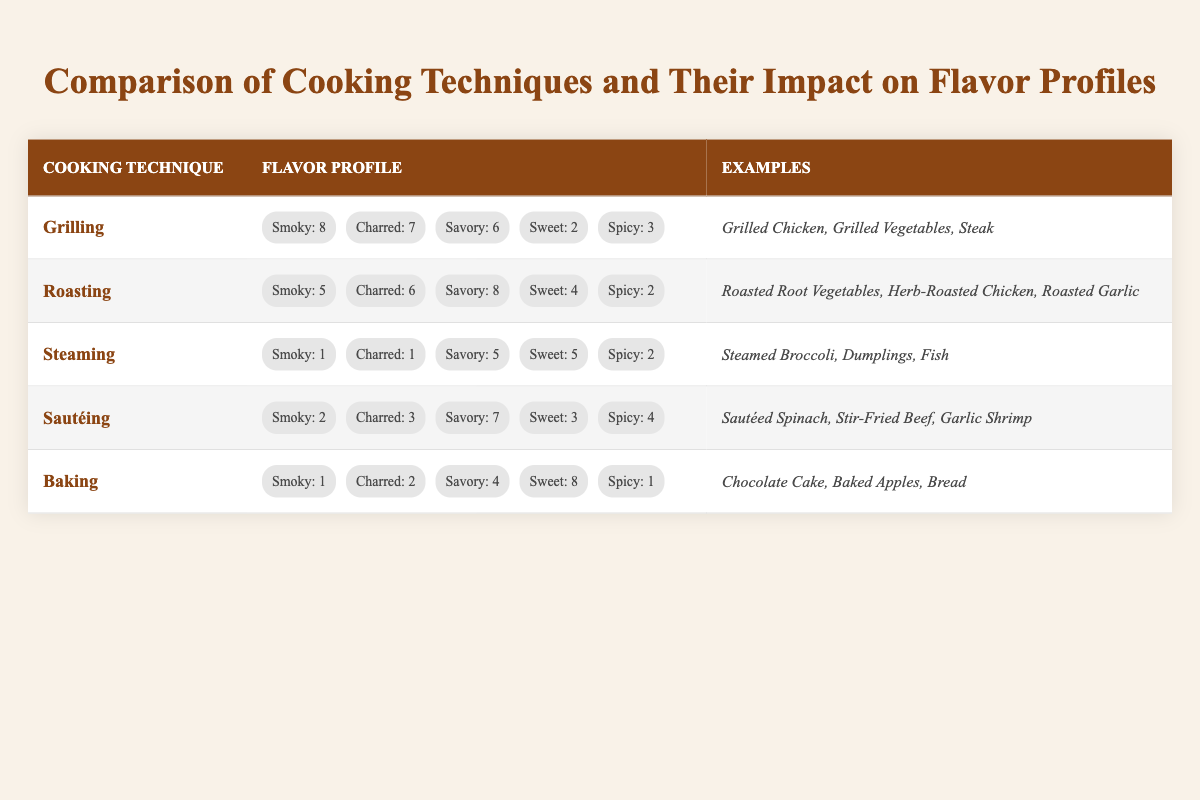What is the flavor profile score for grilling? The flavor profile scores for grilling are as follows: Smoky: 8, Charred: 7, Savory: 6, Sweet: 2, Spicy: 3. These values can be found directly in the table under the grilling technique row.
Answer: Smoky: 8, Charred: 7, Savory: 6, Sweet: 2, Spicy: 3 Which cooking technique has the highest score for sweetness? The scores for sweetness in each cooking technique are: Grilling: 2, Roasting: 4, Steaming: 5, Sautéing: 3, and Baking: 8. Therefore, Baking has the highest score with a value of 8.
Answer: Baking: 8 Are there any cooking techniques that do not have a charred flavor profile? By examining the table, Steaming and Baking have charred flavor profile scores of 1 and 2 respectively. Therefore, while none of the techniques completely lack charred flavor, Steaming has the lowest charred score.
Answer: No What is the difference in savory flavor profile scores between roasting and sautéing? Roasting has a savory score of 8, while sautéing has a savory score of 7. The difference is calculated as 8 - 7 = 1.
Answer: 1 Which cooking technique has the most balanced flavor profile overall? To determine the balance, we can consider the range from the lowest to the highest scores across each technique. The scores are as follows: Grilling (2-8), Roasting (4-8), Steaming (1-5), Sautéing (3-7), and Baking (1-8). Roasting shows a balance of scores between 4 and 8, indicating a less drastic range compared to others.
Answer: Roasting What are the examples of cooking techniques that have a savory score of 6 or higher? The techniques with a savory score of 6 or higher are Grilling (6), Roasting (8), and Sautéing (7). The examples provided in the table for these techniques include: Grilled Chicken, Roasted Root Vegetables, and Sautéed Spinach.
Answer: Grilling, Roasting, Sautéing What is the average score for spiciness across all cooking techniques? To find the average spiciness, sum the spiciness scores: Grilling (3) + Roasting (2) + Steaming (2) + Sautéing (4) + Baking (1) = 12. There are 5 techniques, so the average is 12 / 5 = 2.4.
Answer: 2.4 Which cooking technique features the highest level of smokiness and what is its score? Grilling boasts the highest score for smokiness at 8. This score can be found directly under the grilling row in the table.
Answer: Grilling: 8 